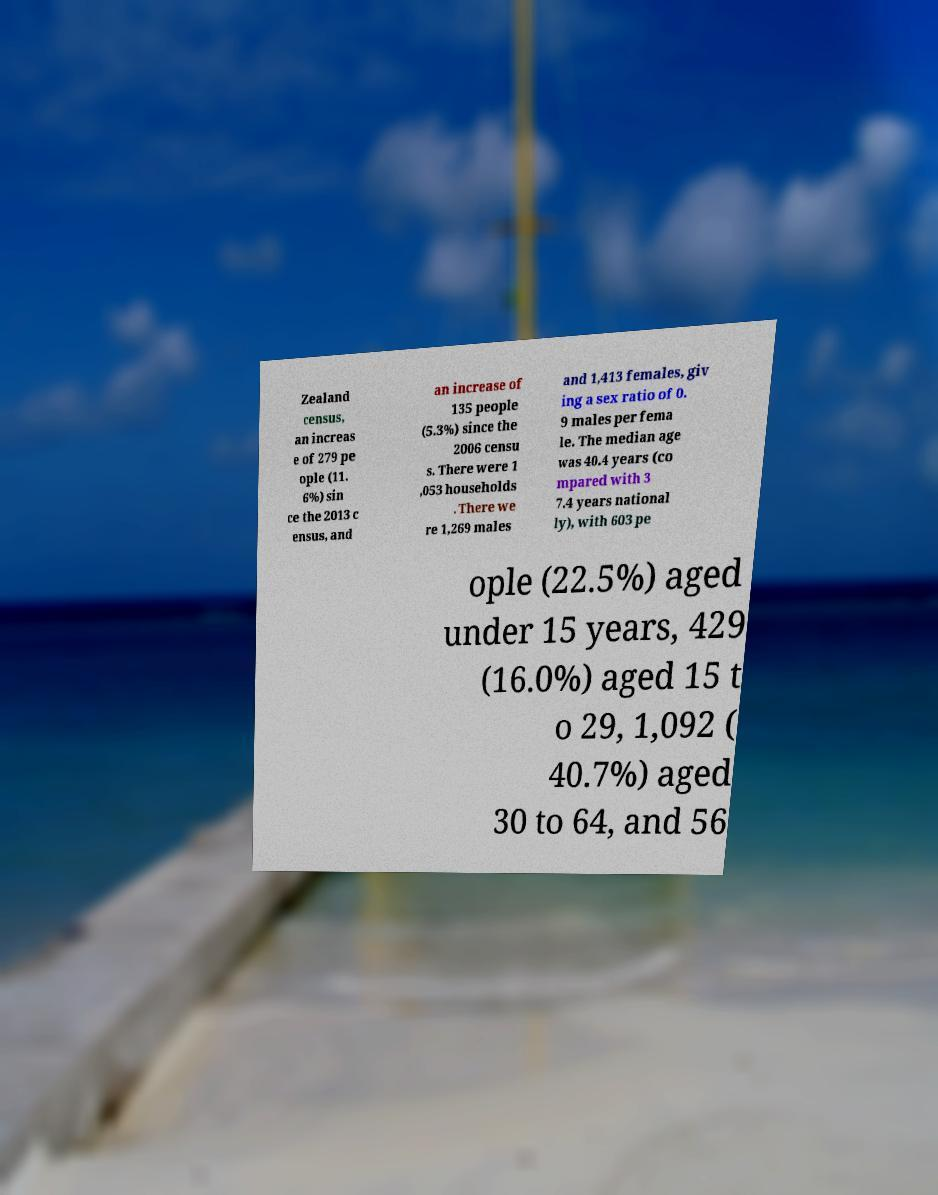Could you assist in decoding the text presented in this image and type it out clearly? Zealand census, an increas e of 279 pe ople (11. 6%) sin ce the 2013 c ensus, and an increase of 135 people (5.3%) since the 2006 censu s. There were 1 ,053 households . There we re 1,269 males and 1,413 females, giv ing a sex ratio of 0. 9 males per fema le. The median age was 40.4 years (co mpared with 3 7.4 years national ly), with 603 pe ople (22.5%) aged under 15 years, 429 (16.0%) aged 15 t o 29, 1,092 ( 40.7%) aged 30 to 64, and 56 